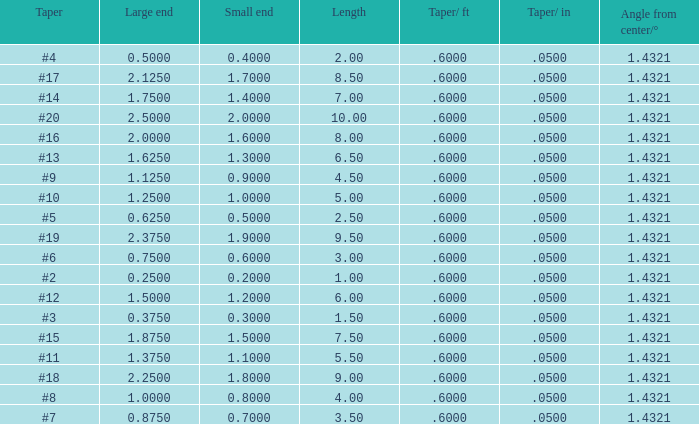Which Length has a Taper of #15, and a Large end larger than 1.875? None. 